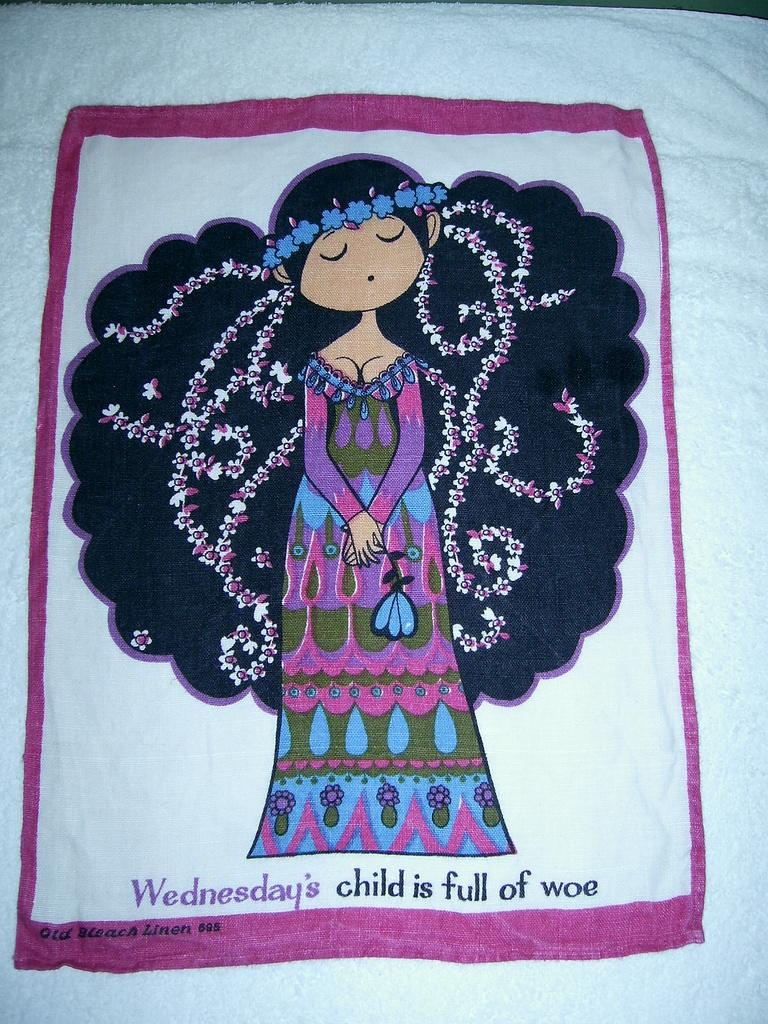What is the main object in the image? There is a cloth in the image. What is depicted on the cloth? The cloth has a printed design of a doll. Are there any words or letters on the cloth? Yes, the cloth has text on it. What adjustment does the maid make to the cloth in the image? There is no maid present in the image, and no adjustment is being made to the cloth. 